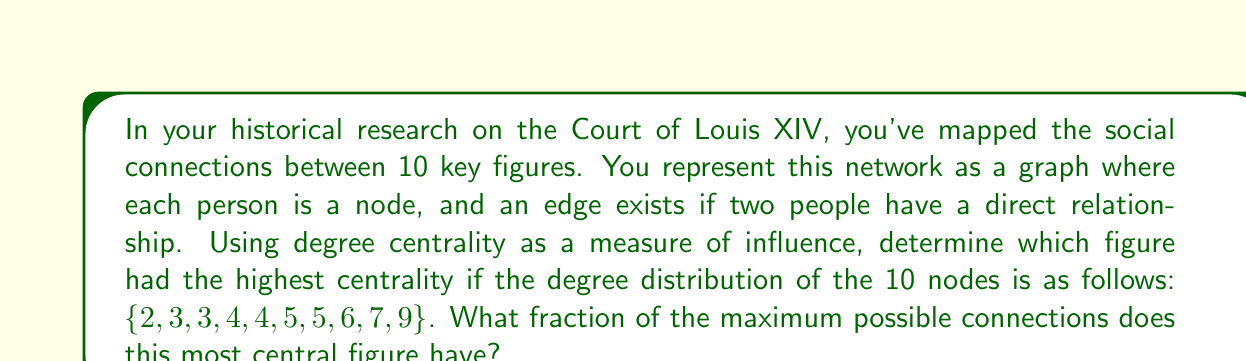Help me with this question. To solve this problem, we'll follow these steps:

1) First, recall that degree centrality is simply the number of connections (degree) a node has in an undirected graph.

2) From the given degree distribution, we can see that the highest degree is 9. This represents the most central figure in the network.

3) To calculate the fraction of maximum possible connections, we need to determine the maximum possible connections and then divide the actual connections by this number.

4) In a network with 10 nodes, each node could potentially connect to 9 others (excluding itself). So the maximum possible degree for any node is 9.

5) The fraction of maximum connections is thus:

   $$\frac{\text{Actual connections}}{\text{Maximum possible connections}} = \frac{9}{9} = 1$$

6) To express this as a fraction, we don't need to simplify further as 1 is already in its simplest form.

This result indicates that the most central figure is connected to all other figures in the network, suggesting they held a position of significant influence in Louis XIV's court according to this model.
Answer: 1 